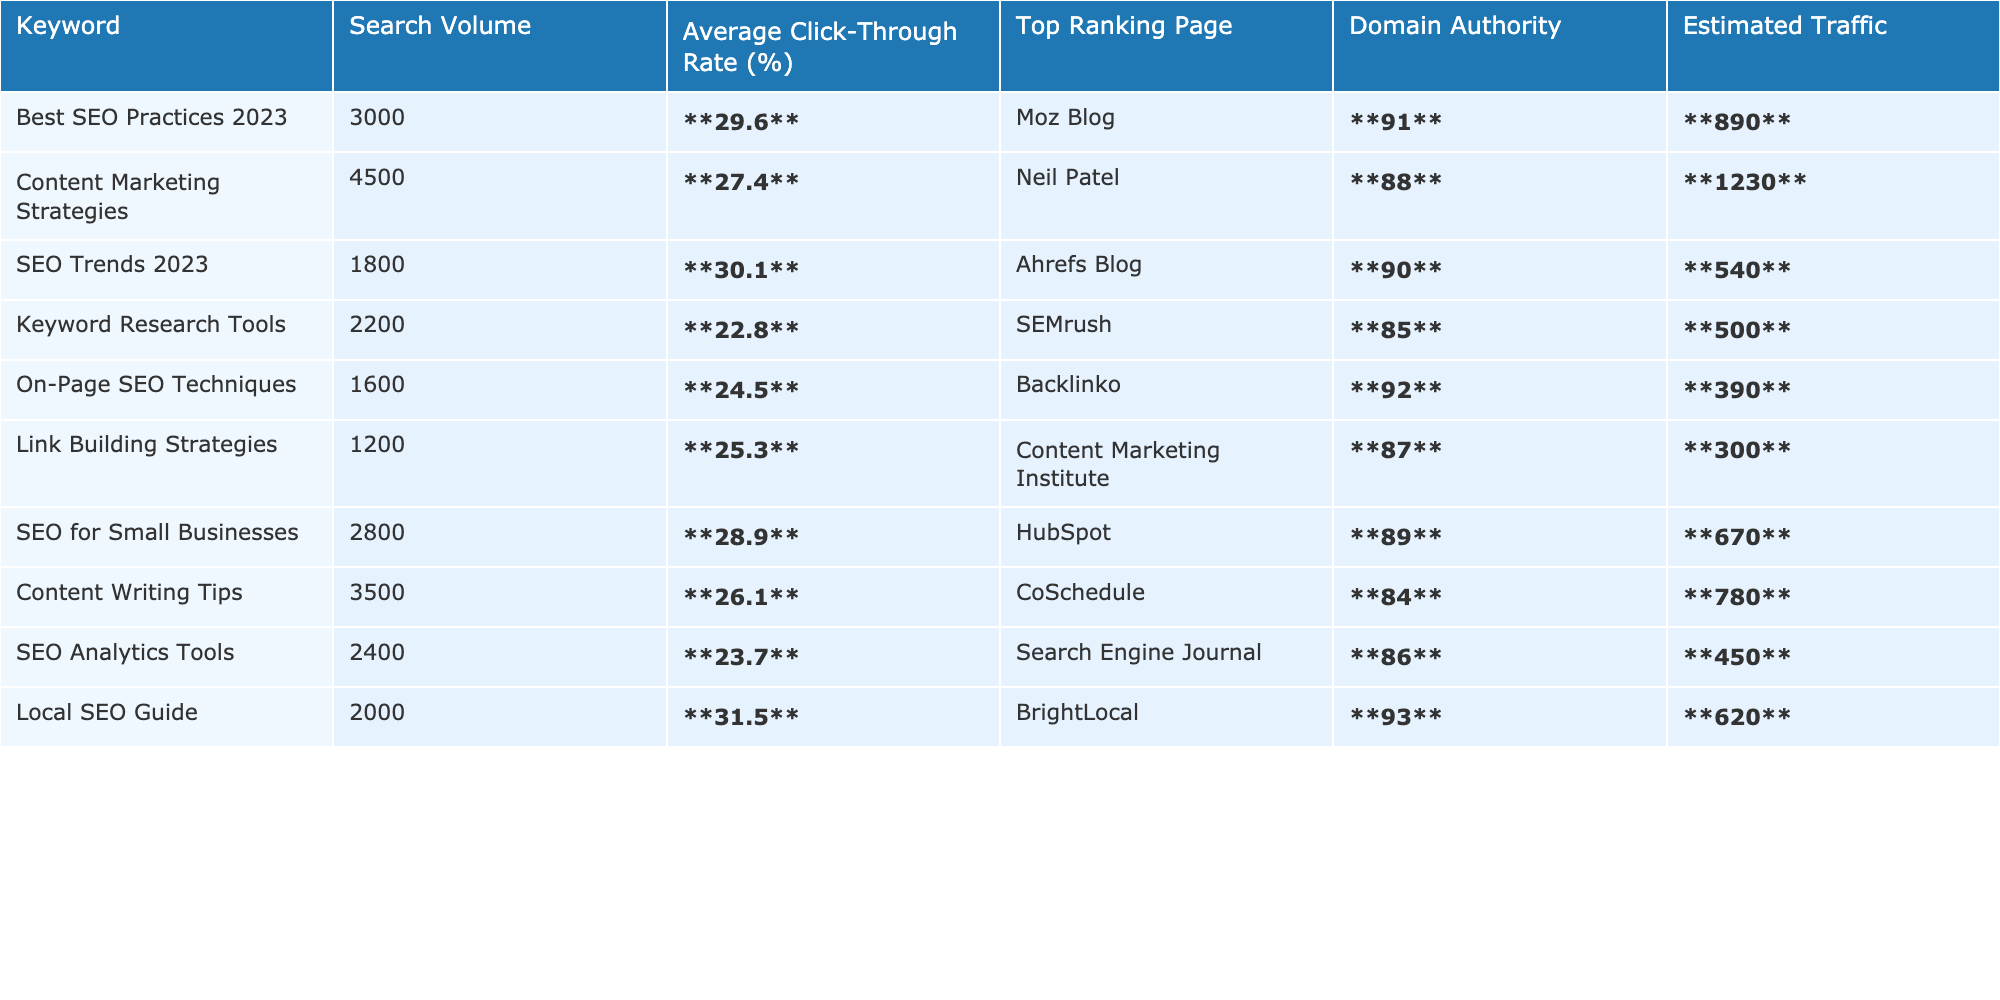What's the click-through rate for the keyword "SEO Trends 2023"? The table shows that the average click-through rate for "SEO Trends 2023" is **30.1%**.
Answer: 30.1% Which keyword has the highest estimated traffic? By reviewing the table, "Best SEO Practices 2023" has the highest estimated traffic at **890**.
Answer: 890 What is the domain authority of the page ranking for "Local SEO Guide"? The table indicates that the domain authority for "Local SEO Guide" is **93**.
Answer: 93 Calculate the average click-through rate for all keywords in the table. The click-through rates for all keywords are 29.6, 27.4, 30.1, 22.8, 24.5, 25.3, 28.9, 26.1, 23.7, and 31.5. Adding these gives  29.6 + 27.4 + 30.1 + 22.8 + 24.5 + 25.3 + 28.9 + 26.1 + 23.7 + 31.5 =  29.49 (approximately), and dividing by 10 gives an average of **27.99%**.
Answer: 27.99% Is the estimated traffic for "Keyword Research Tools" greater than the average estimated traffic of all keywords? The estimated traffic for "Keyword Research Tools" is **500**. The average estimated traffic is (890 + 1230 + 540 + 500 + 390 + 300 + 670 + 780 + 450 + 620) = 6,080/10 = **608**. Since 500 is less than 608, the answer is NO.
Answer: NO Which keyword has the highest domain authority, and what is the value? Scanning the table, "Local SEO Guide" has the highest domain authority of **93**.
Answer: 93 Are there any keywords with an average click-through rate below 25%? Reviewing the table, "Keyword Research Tools" (22.8), "On-Page SEO Techniques" (24.5), and "SEO Analytics Tools" (23.7) all have rates below 25%. Thus, the answer is YES.
Answer: YES What is the difference in estimated traffic between "Content Marketing Strategies" and "Link Building Strategies"? The estimated traffic for "Content Marketing Strategies" is **1230**, and for "Link Building Strategies" it is **300**. The difference is 1230 - 300 = **930**.
Answer: 930 Which keyword has the lowest average click-through rate and what is that rate? The table indicates that the keyword with the lowest click-through rate is "Keyword Research Tools" at **22.8%**.
Answer: 22.8% List all keywords with domain authority greater than 90. The keywords with domain authority greater than 90 are "Moz Blog" (91), "Backlinko" (92), and "BrightLocal" (93).
Answer: Moz Blog, Backlinko, BrightLocal How many keywords have an estimated traffic of more than 700? The keywords with estimated traffic higher than 700 are: "Best SEO Practices 2023" (890), "Content Marketing Strategies" (1230), "SEO for Small Businesses" (670), "Content Writing Tips" (780). Counting these gives us a total of **4**.
Answer: 4 